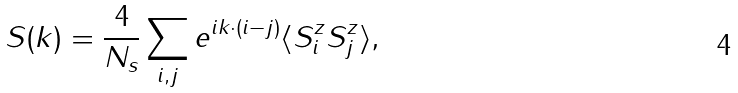<formula> <loc_0><loc_0><loc_500><loc_500>S ( { k } ) = \frac { 4 } { N _ { s } } \sum _ { { i } , { j } } e ^ { i { k } \cdot ( { i } - { j } ) } \langle { S } ^ { z } _ { i } { S } ^ { z } _ { j } \rangle ,</formula> 